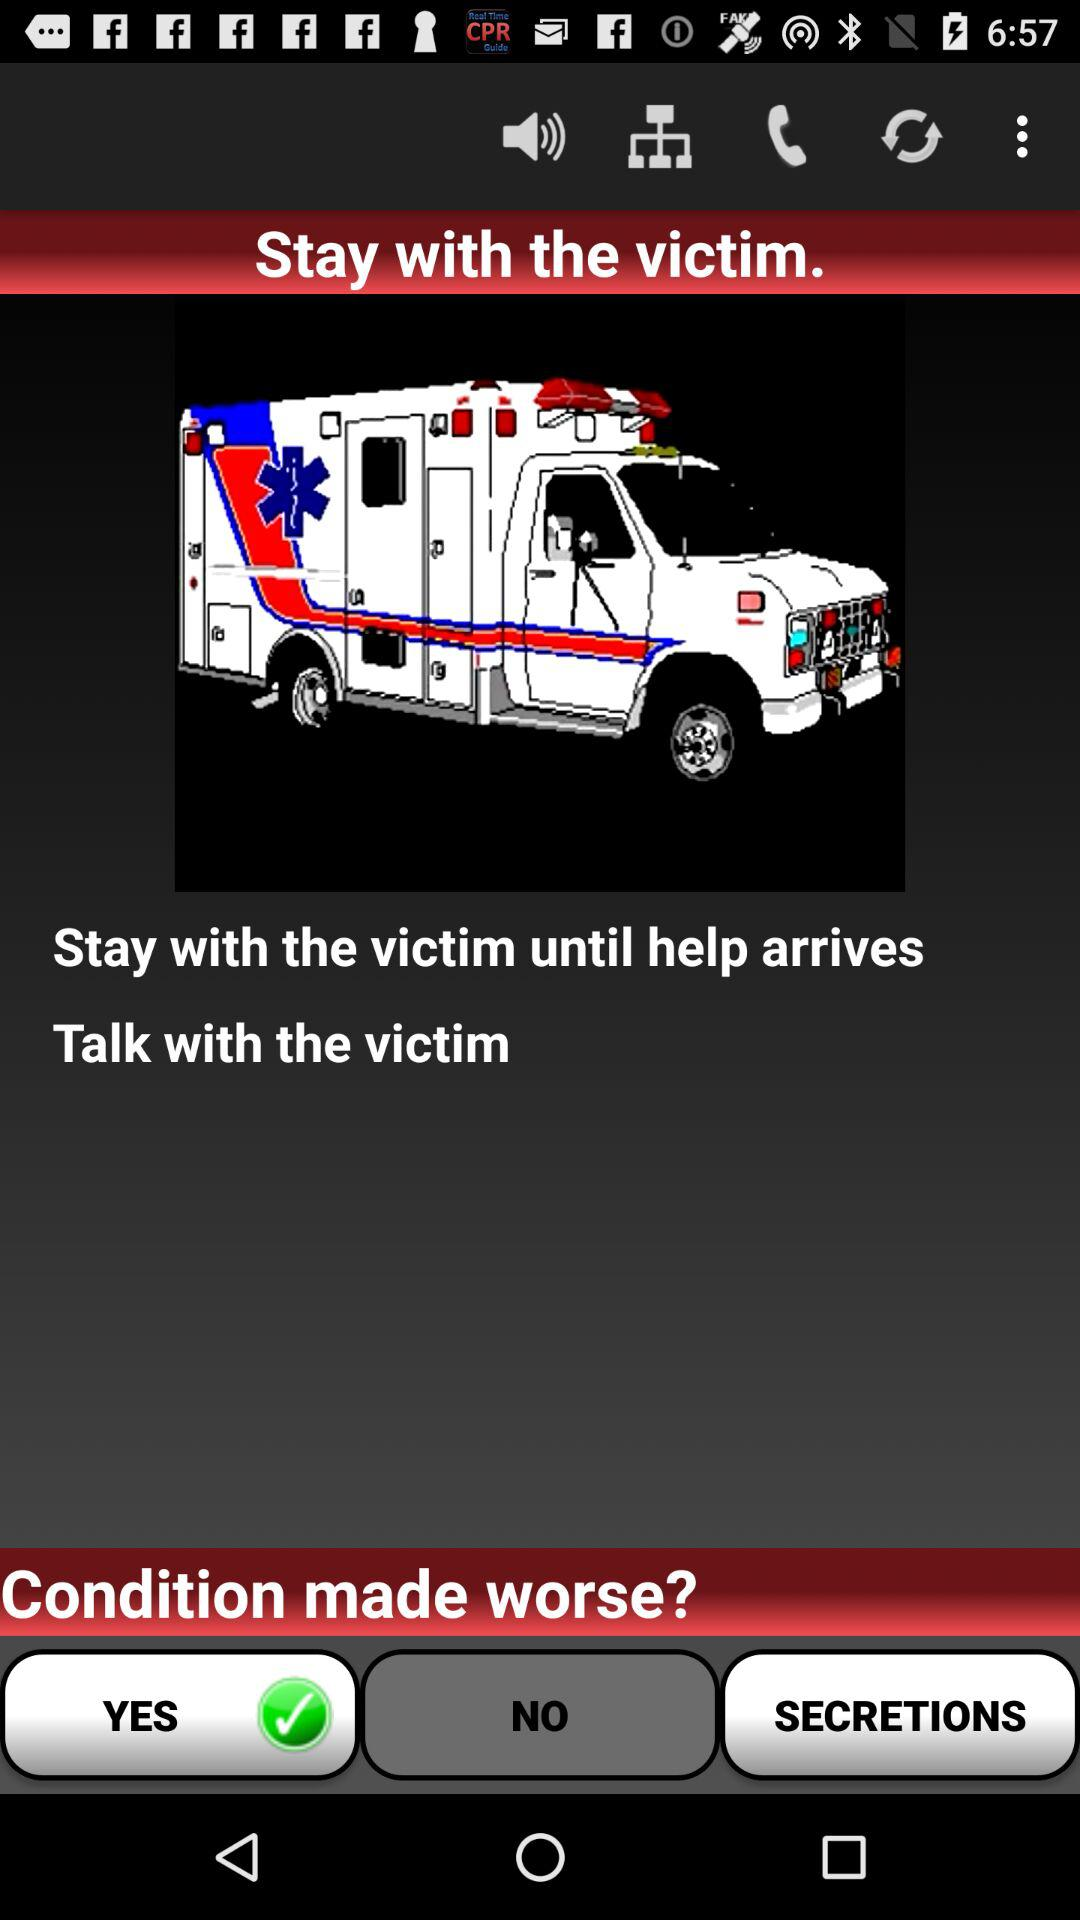What is the victim's condition?
When the provided information is insufficient, respond with <no answer>. <no answer> 